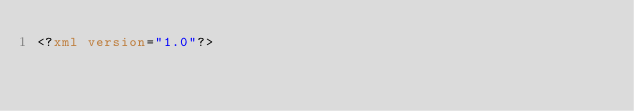Convert code to text. <code><loc_0><loc_0><loc_500><loc_500><_XML_><?xml version="1.0"?></code> 